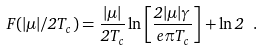Convert formula to latex. <formula><loc_0><loc_0><loc_500><loc_500>F ( | \mu | / 2 T _ { c } ) = \frac { | \mu | } { 2 T _ { c } } \ln \left [ \frac { 2 | \mu | \gamma } { e \pi T _ { c } } \right ] + \ln 2 \ .</formula> 